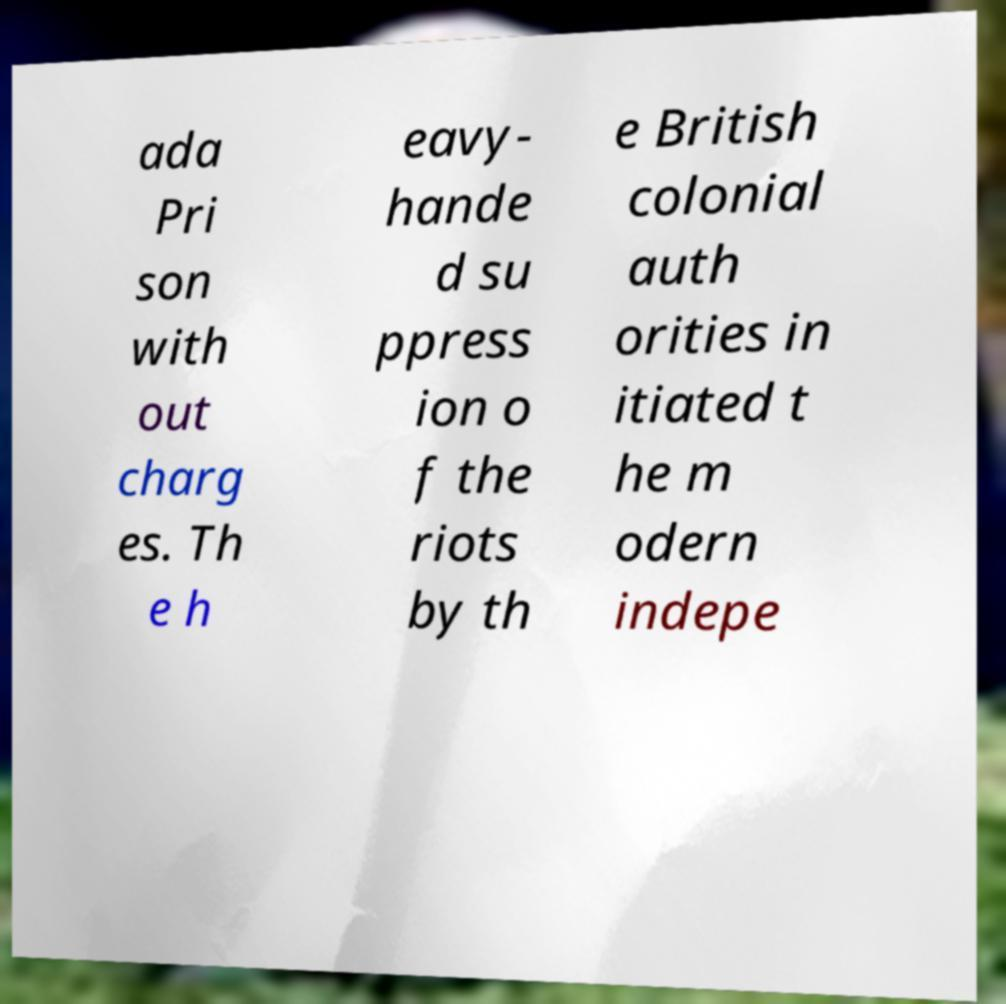Can you read and provide the text displayed in the image?This photo seems to have some interesting text. Can you extract and type it out for me? ada Pri son with out charg es. Th e h eavy- hande d su ppress ion o f the riots by th e British colonial auth orities in itiated t he m odern indepe 